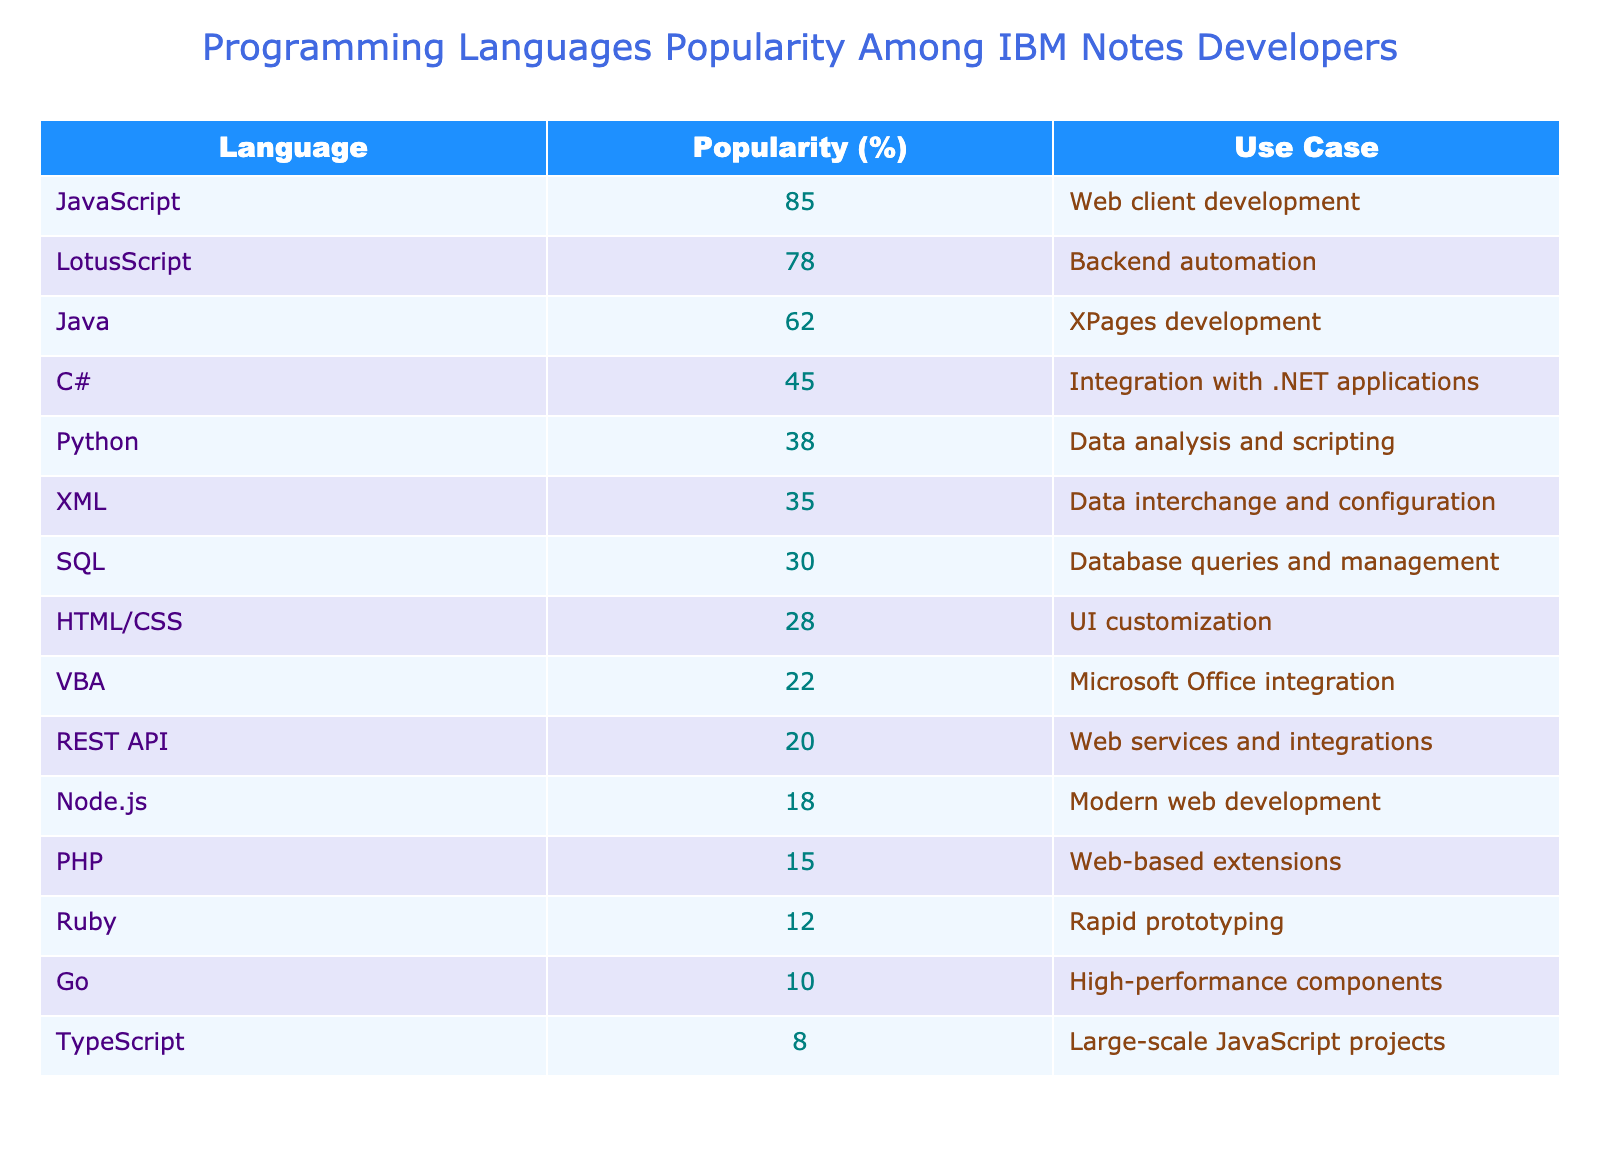What is the most popular programming language among IBM Notes developers? The table indicates that JavaScript has the highest popularity at 85%.
Answer: JavaScript What percentage of developers use LotusScript? According to the table, LotusScript is used by 78% of developers.
Answer: 78% Is SQL the least popular programming language in this table? From the data, SQL has a popularity of 30%, which is higher than PHP's 15% and Ruby's 12%. Thus, it is not the least popular language.
Answer: No What is the average popularity percentage of the top three languages listed? The top three languages are JavaScript (85%), LotusScript (78%), and Java (62%). Their total is 85 + 78 + 62 = 225. Dividing by 3 gives an average of 225 / 3 = 75.
Answer: 75 Which language has a popularity percentage closest to the average of all the languages listed? First, we calculate the total popularity: 85 + 78 + 62 + 45 + 38 + 35 + 30 + 28 + 22 + 20 + 18 + 15 + 12 + 10 + 8 =  469. Dividing by 15 gives an average of approximately 31.27. The closest values are SQL (30%) and XML (35%).
Answer: SQL and XML How many programming languages have a popularity of over 50%? The languages with over 50% popularity are JavaScript (85%), LotusScript (78%), and Java (62); therefore, there are three languages in total.
Answer: 3 Is Python more popular than HTML/CSS among IBM Notes developers? Python's popularity is 38% while HTML/CSS is 28%. Since 38% > 28%, Python is indeed more popular.
Answer: Yes What is the difference in popularity between the most popular and the least popular programming languages in the table? The most popular language is JavaScript at 85%, and the least popular is Ruby at 12%. The difference is 85 - 12 = 73.
Answer: 73 How many languages listed have a popularity of less than 20%? The languages with less than 20% popularity are Node.js (18%), PHP (15%), and Ruby (12%). This results in a total of three languages.
Answer: 3 What is the total popularity percentage of all programming languages mentioned in this table? Adding all the popularity percentages together yields 85 + 78 + 62 + 45 + 38 + 35 + 30 + 28 + 22 + 20 + 18 + 15 + 12 + 10 + 8 = 469.
Answer: 469 